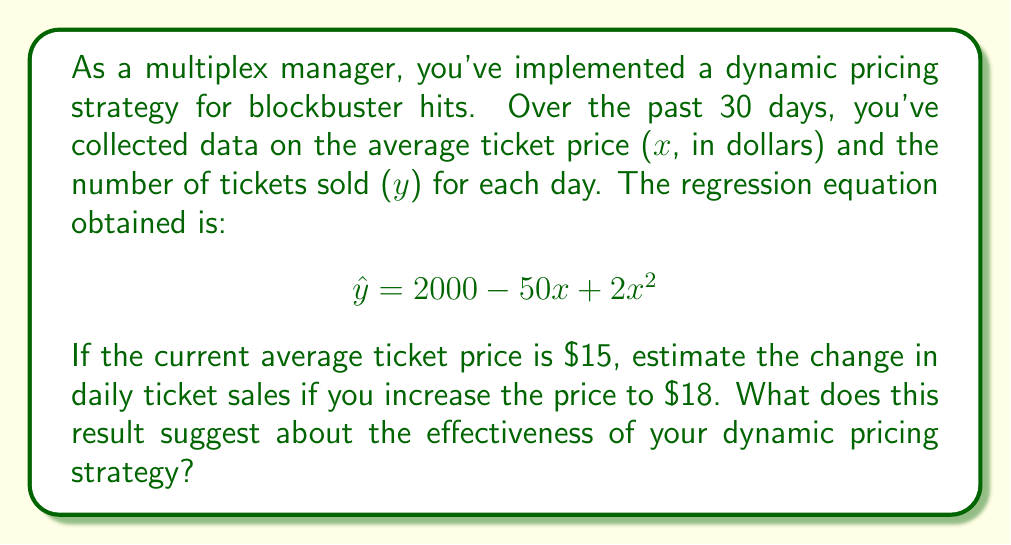Could you help me with this problem? To solve this problem, we'll follow these steps:

1. Calculate the estimated number of tickets sold at the current price ($15).
2. Calculate the estimated number of tickets sold at the new price ($18).
3. Find the difference between these two estimates.
4. Interpret the result in the context of the dynamic pricing strategy.

Step 1: Estimated tickets sold at $15
$$ \hat{y} = 2000 - 50(15) + 2(15)^2 $$
$$ \hat{y} = 2000 - 750 + 2(225) $$
$$ \hat{y} = 2000 - 750 + 450 = 1700 $$

Step 2: Estimated tickets sold at $18
$$ \hat{y} = 2000 - 50(18) + 2(18)^2 $$
$$ \hat{y} = 2000 - 900 + 2(324) $$
$$ \hat{y} = 2000 - 900 + 648 = 1748 $$

Step 3: Difference in estimated ticket sales
$$ \Delta \hat{y} = 1748 - 1700 = 48 $$

Step 4: Interpretation
The positive change in ticket sales (48 additional tickets) suggests that the dynamic pricing strategy is effective. Increasing the average ticket price from $15 to $18 is estimated to result in higher ticket sales, indicating that the strategy can potentially increase both revenue and attendance.

This outcome is possible due to the quadratic term in the regression equation, which allows for a non-linear relationship between price and ticket sales. In this case, the positive coefficient of the quadratic term ($2x^2$) suggests that at higher prices, the negative impact of increased price on sales is outweighed by other factors, possibly including perceived value, exclusivity, or improved amenities associated with premium pricing.
Answer: The estimated change in daily ticket sales is an increase of 48 tickets. This suggests that the dynamic pricing strategy is effective, as it can potentially increase both ticket sales and revenue. 